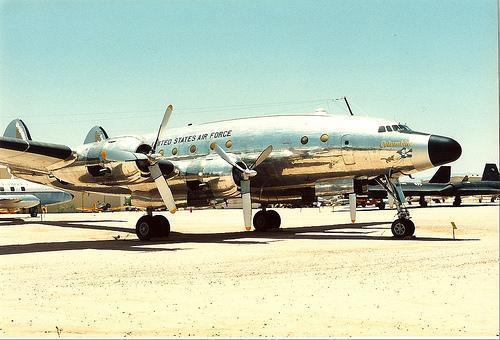How many engines are on the right side of the plane?
Give a very brief answer. 2. 